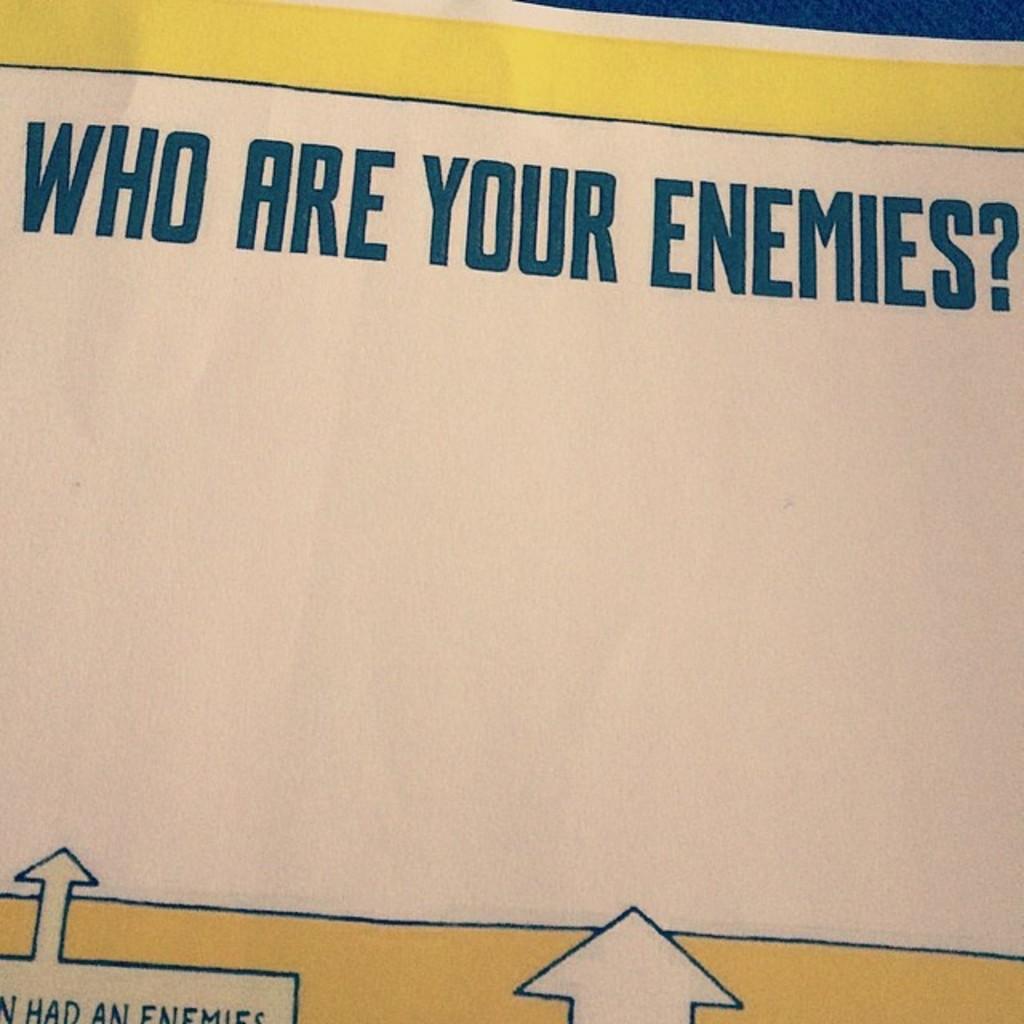What is being asked?
Offer a terse response. Who are your enemies?. 